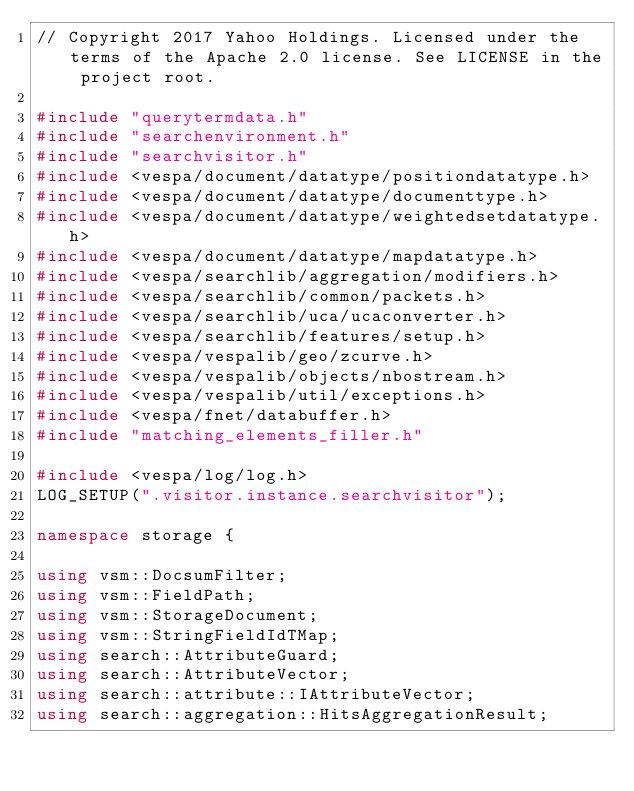Convert code to text. <code><loc_0><loc_0><loc_500><loc_500><_C++_>// Copyright 2017 Yahoo Holdings. Licensed under the terms of the Apache 2.0 license. See LICENSE in the project root.

#include "querytermdata.h"
#include "searchenvironment.h"
#include "searchvisitor.h"
#include <vespa/document/datatype/positiondatatype.h>
#include <vespa/document/datatype/documenttype.h>
#include <vespa/document/datatype/weightedsetdatatype.h>
#include <vespa/document/datatype/mapdatatype.h>
#include <vespa/searchlib/aggregation/modifiers.h>
#include <vespa/searchlib/common/packets.h>
#include <vespa/searchlib/uca/ucaconverter.h>
#include <vespa/searchlib/features/setup.h>
#include <vespa/vespalib/geo/zcurve.h>
#include <vespa/vespalib/objects/nbostream.h>
#include <vespa/vespalib/util/exceptions.h>
#include <vespa/fnet/databuffer.h>
#include "matching_elements_filler.h"

#include <vespa/log/log.h>
LOG_SETUP(".visitor.instance.searchvisitor");

namespace storage {

using vsm::DocsumFilter;
using vsm::FieldPath;
using vsm::StorageDocument;
using vsm::StringFieldIdTMap;
using search::AttributeGuard;
using search::AttributeVector;
using search::attribute::IAttributeVector;
using search::aggregation::HitsAggregationResult;</code> 